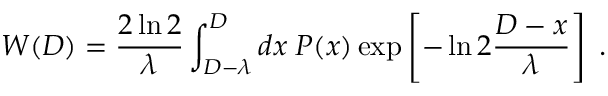Convert formula to latex. <formula><loc_0><loc_0><loc_500><loc_500>W ( D ) = \frac { 2 \ln 2 } { \lambda } \int _ { D - \lambda } ^ { D } d x \, P ( x ) \exp \left [ - \ln 2 \frac { D - x } { \lambda } \right ] \, .</formula> 